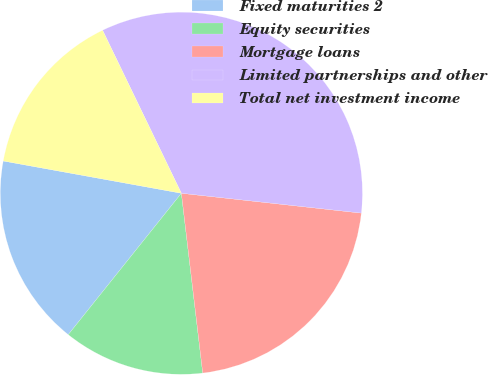Convert chart. <chart><loc_0><loc_0><loc_500><loc_500><pie_chart><fcel>Fixed maturities 2<fcel>Equity securities<fcel>Mortgage loans<fcel>Limited partnerships and other<fcel>Total net investment income<nl><fcel>17.11%<fcel>12.62%<fcel>21.37%<fcel>33.91%<fcel>14.98%<nl></chart> 